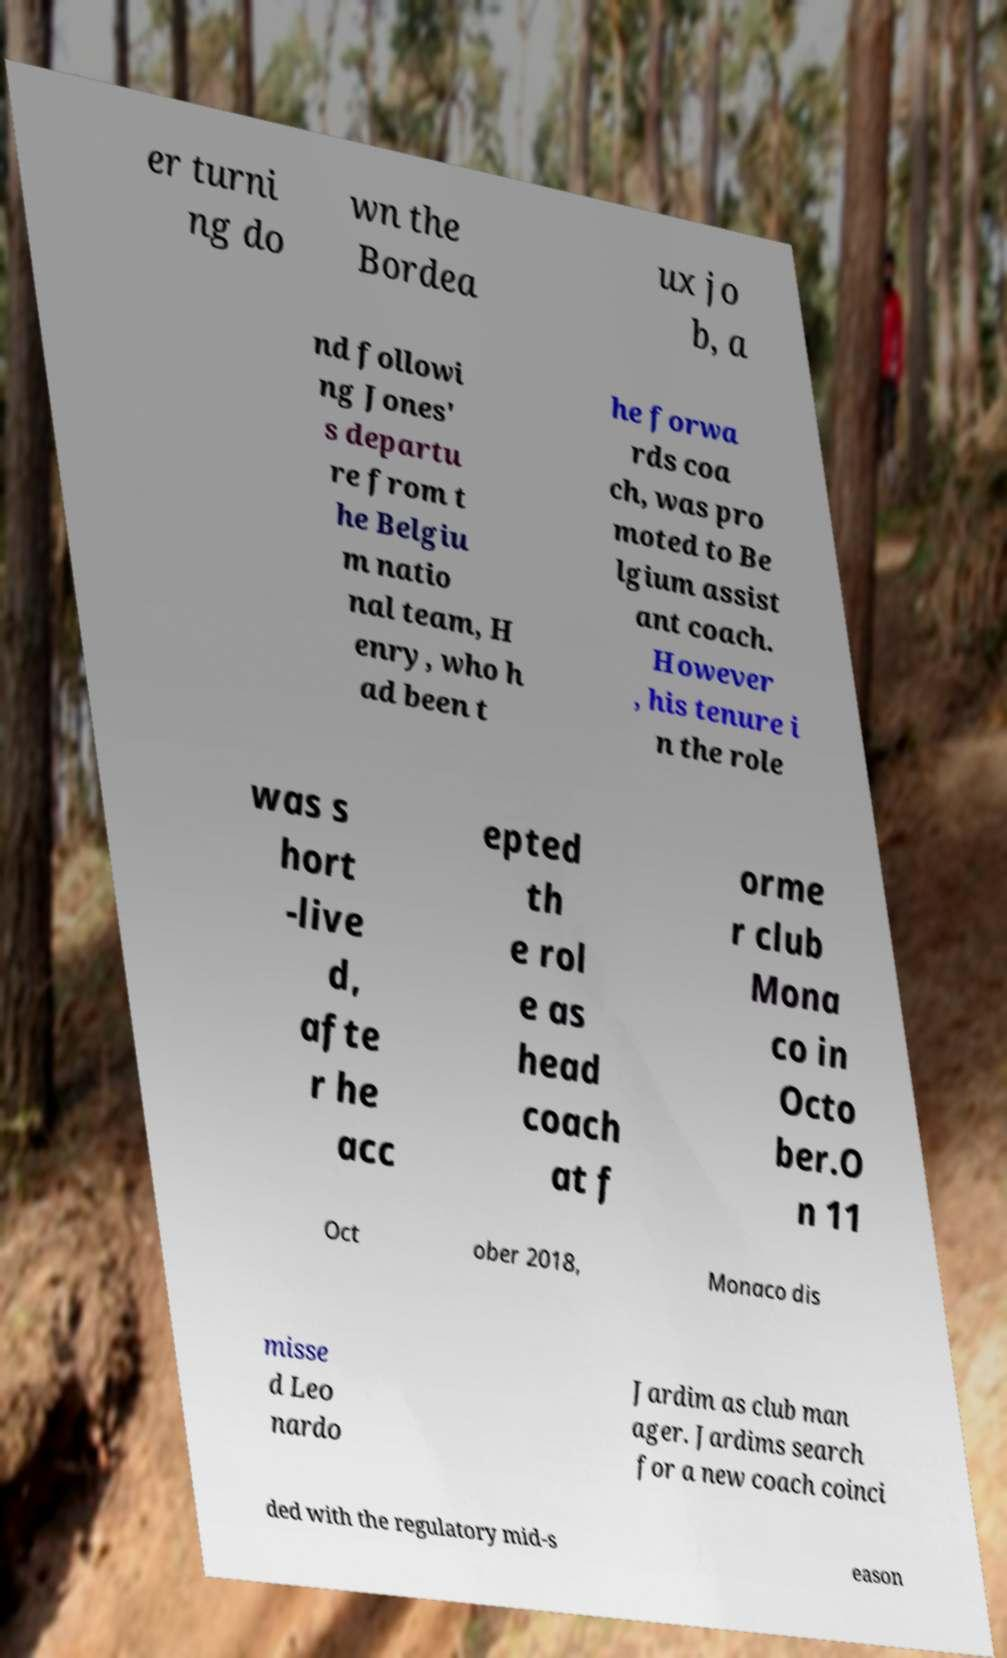Can you accurately transcribe the text from the provided image for me? er turni ng do wn the Bordea ux jo b, a nd followi ng Jones' s departu re from t he Belgiu m natio nal team, H enry, who h ad been t he forwa rds coa ch, was pro moted to Be lgium assist ant coach. However , his tenure i n the role was s hort -live d, afte r he acc epted th e rol e as head coach at f orme r club Mona co in Octo ber.O n 11 Oct ober 2018, Monaco dis misse d Leo nardo Jardim as club man ager. Jardims search for a new coach coinci ded with the regulatory mid-s eason 